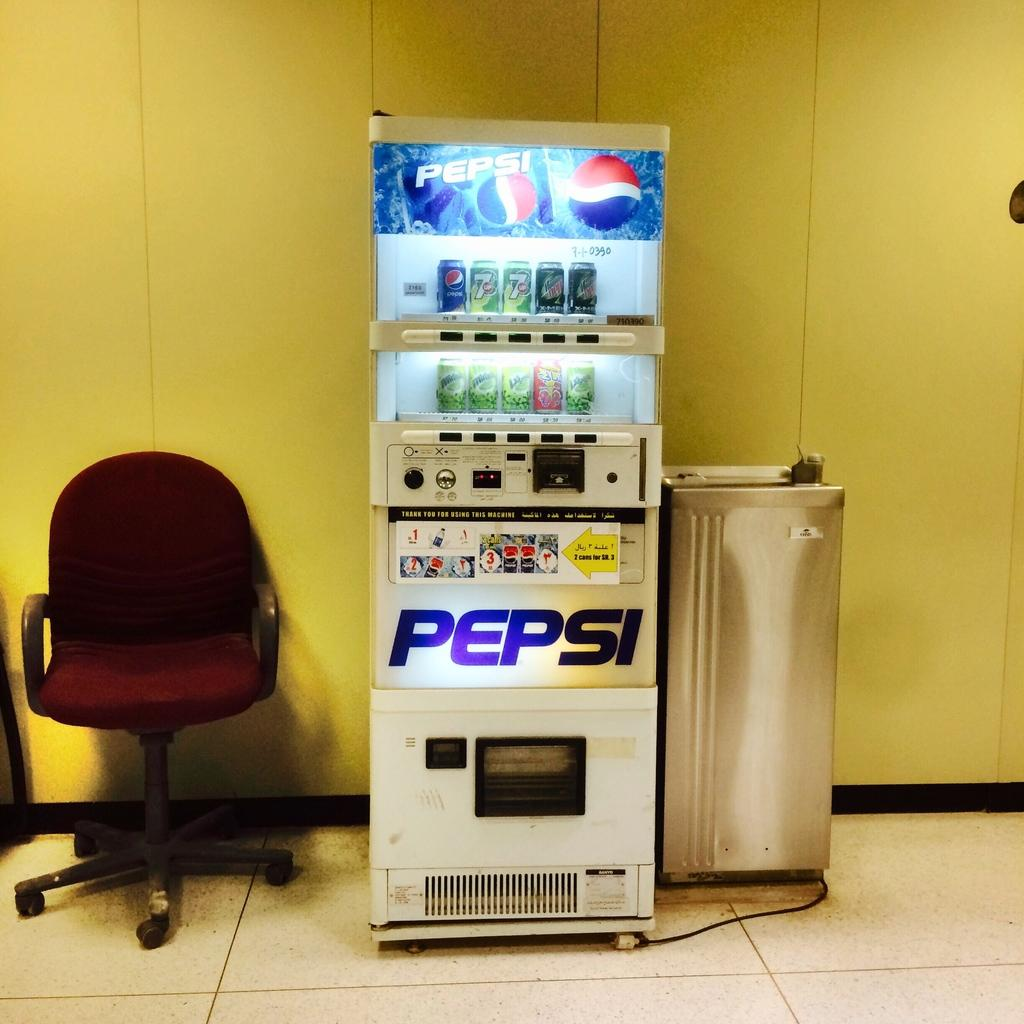<image>
Share a concise interpretation of the image provided. pepsi soda machine sits in a room with yellow walls 